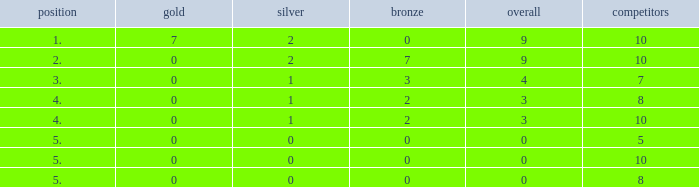What is listed as the highest Gold that also has a Silver that's smaller than 1, and has a Total that's smaller than 0? None. 